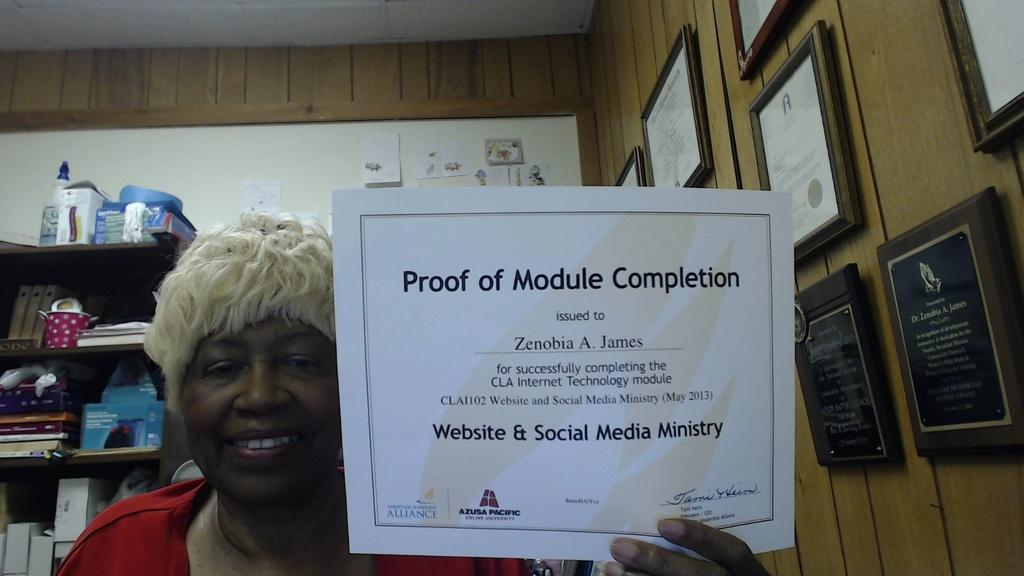What is the person holding in the image? There is a person holding a paper in the image. What can be seen on the wall in the image? There are frames on the wall in the image. What is visible in the background of the image? In the background, there is a rack, books, bottles, and boxes visible. What else is on the wall in the background of the image? Posters are on the wall in the background of the image. How many police officers are visible in the image? There are no police officers present in the image. What type of zipper can be seen on the person's clothing in the image? There is no zipper visible on the person's clothing in the image. 